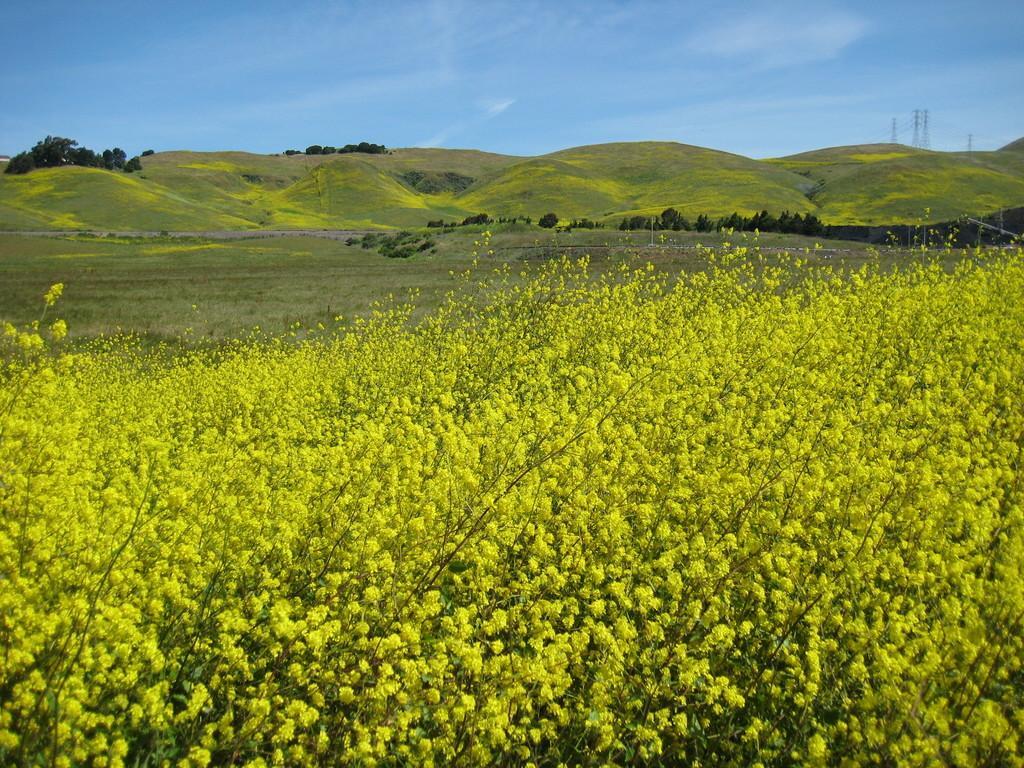Could you give a brief overview of what you see in this image? In this image we can see plants, mountains, the poles and in the background we can see the sky. 